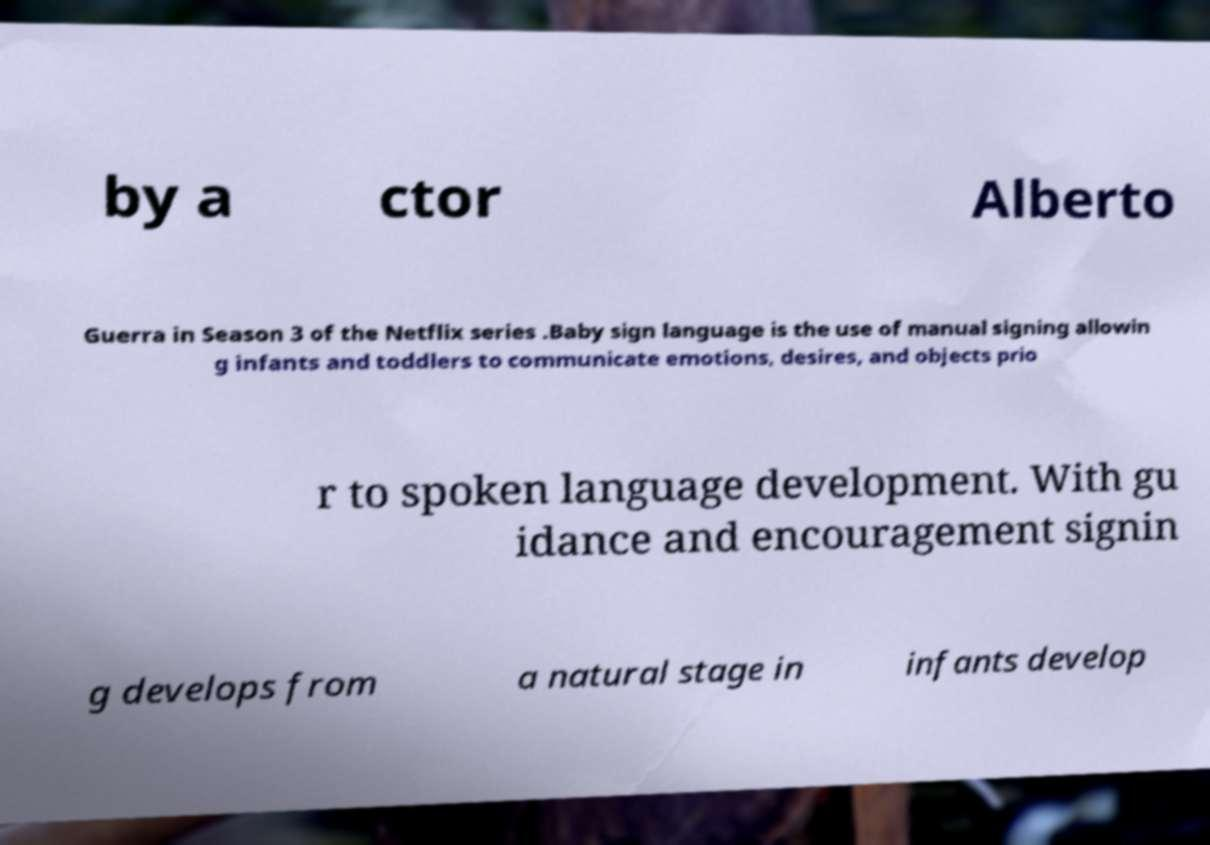There's text embedded in this image that I need extracted. Can you transcribe it verbatim? by a ctor Alberto Guerra in Season 3 of the Netflix series .Baby sign language is the use of manual signing allowin g infants and toddlers to communicate emotions, desires, and objects prio r to spoken language development. With gu idance and encouragement signin g develops from a natural stage in infants develop 